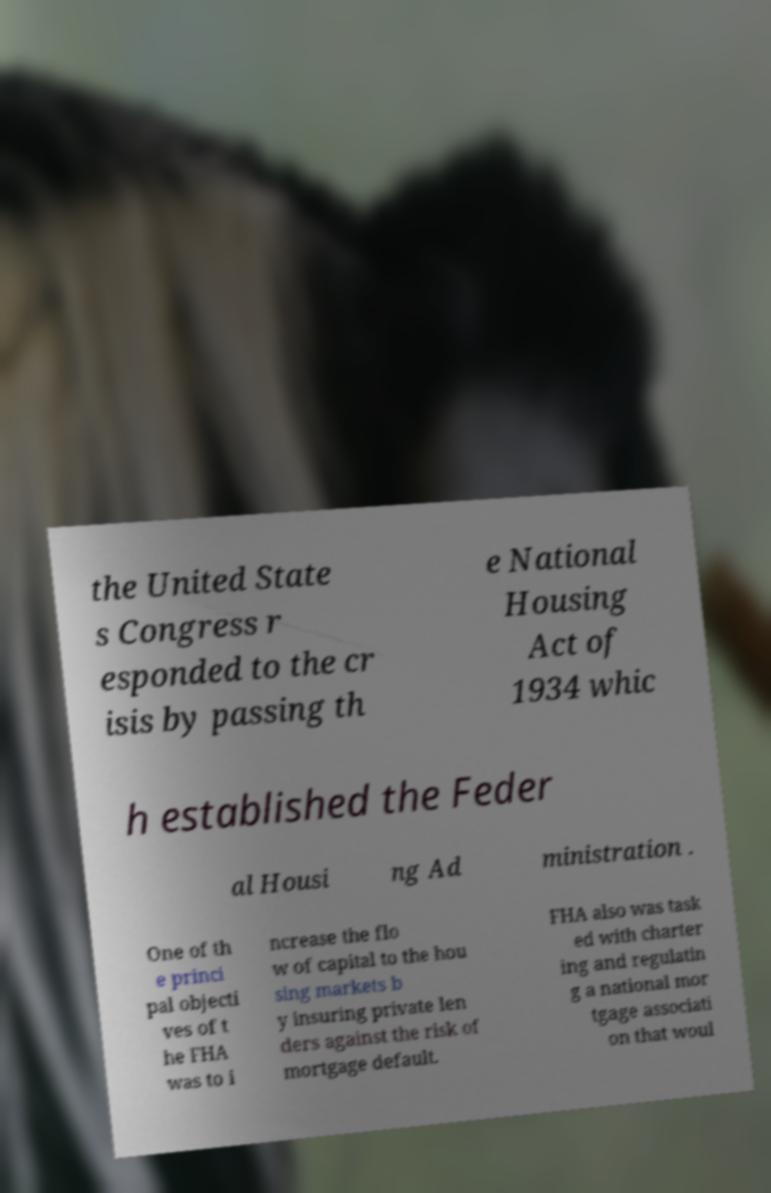Please identify and transcribe the text found in this image. the United State s Congress r esponded to the cr isis by passing th e National Housing Act of 1934 whic h established the Feder al Housi ng Ad ministration . One of th e princi pal objecti ves of t he FHA was to i ncrease the flo w of capital to the hou sing markets b y insuring private len ders against the risk of mortgage default. FHA also was task ed with charter ing and regulatin g a national mor tgage associati on that woul 